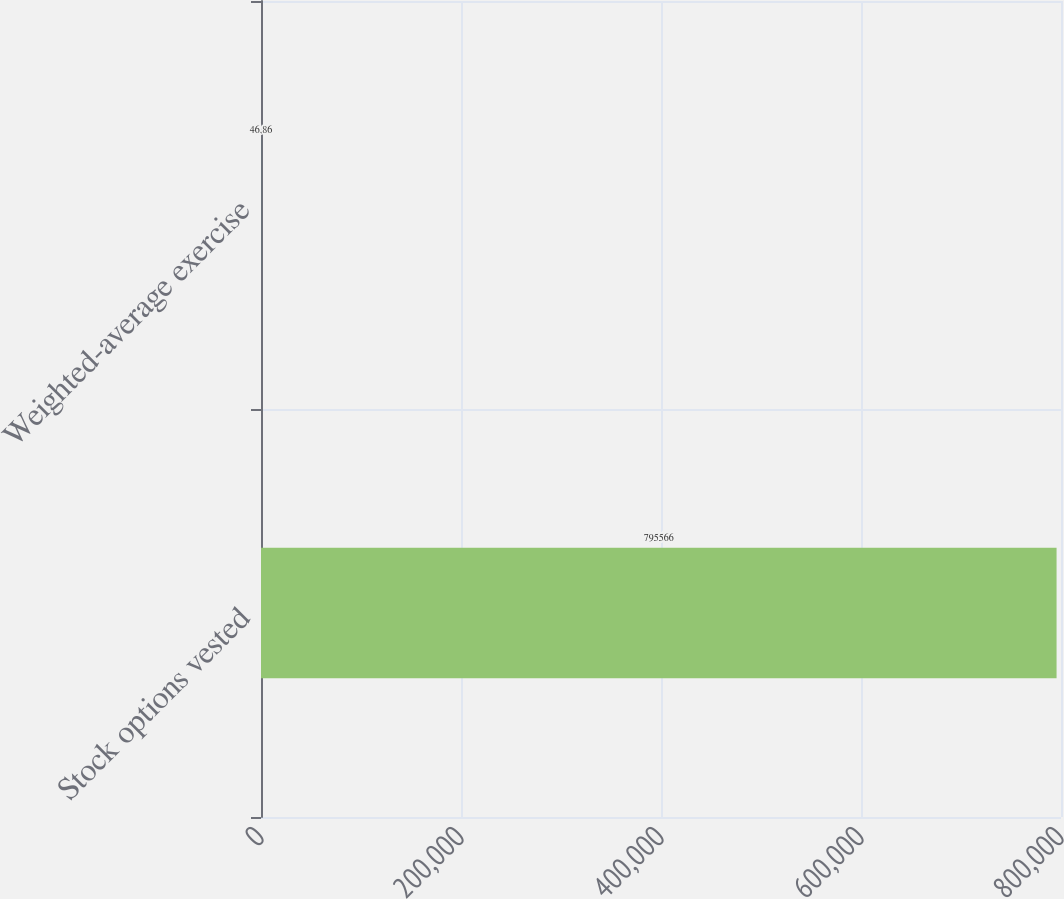<chart> <loc_0><loc_0><loc_500><loc_500><bar_chart><fcel>Stock options vested<fcel>Weighted-average exercise<nl><fcel>795566<fcel>46.86<nl></chart> 